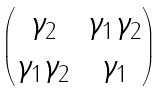<formula> <loc_0><loc_0><loc_500><loc_500>\begin{pmatrix} \gamma _ { 2 } & \gamma _ { 1 } \gamma _ { 2 } \\ \gamma _ { 1 } \gamma _ { 2 } & \gamma _ { 1 } \end{pmatrix}</formula> 